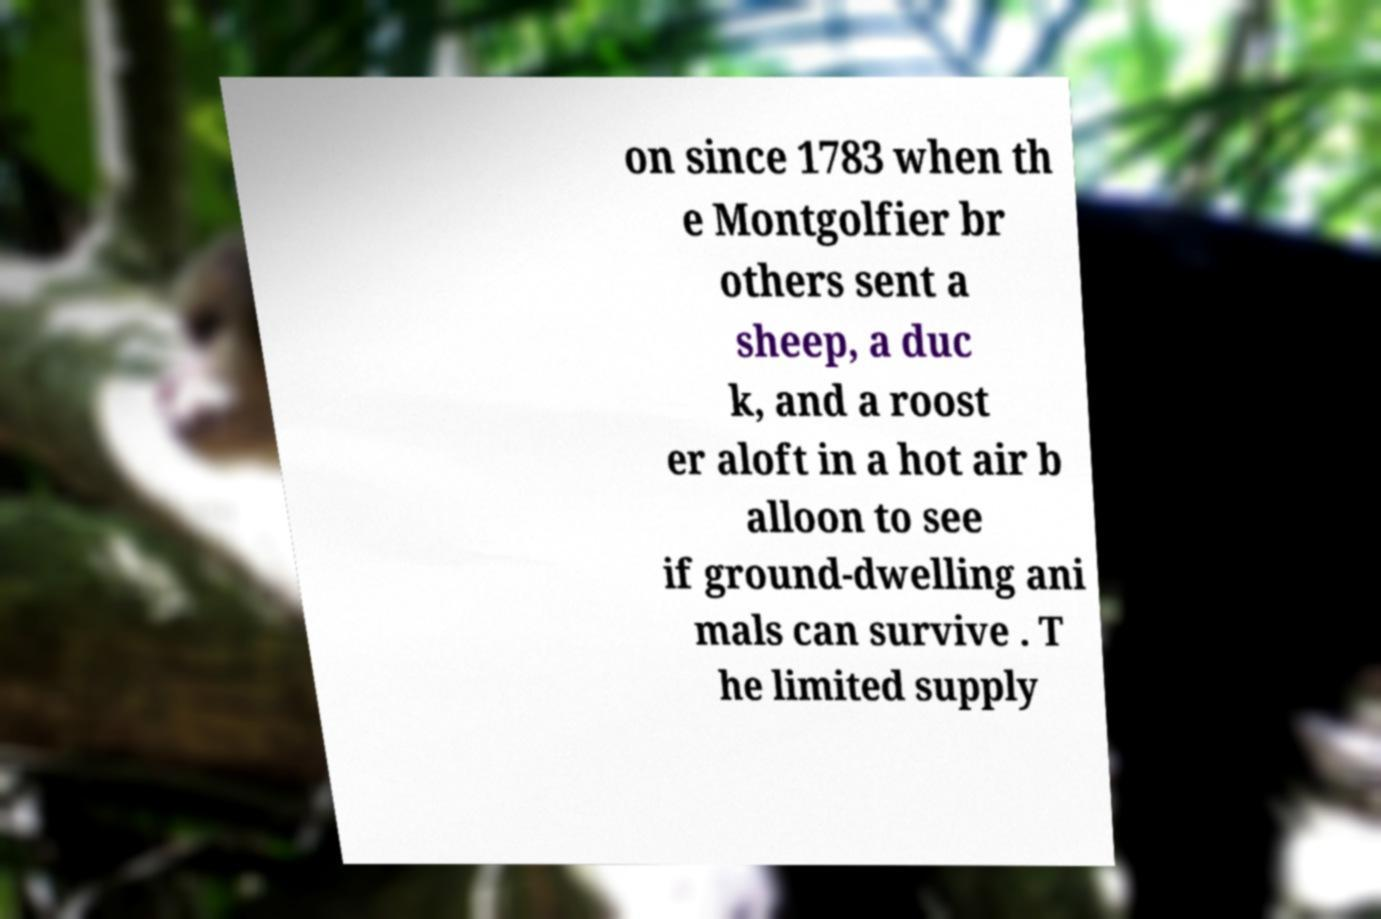Could you extract and type out the text from this image? on since 1783 when th e Montgolfier br others sent a sheep, a duc k, and a roost er aloft in a hot air b alloon to see if ground-dwelling ani mals can survive . T he limited supply 